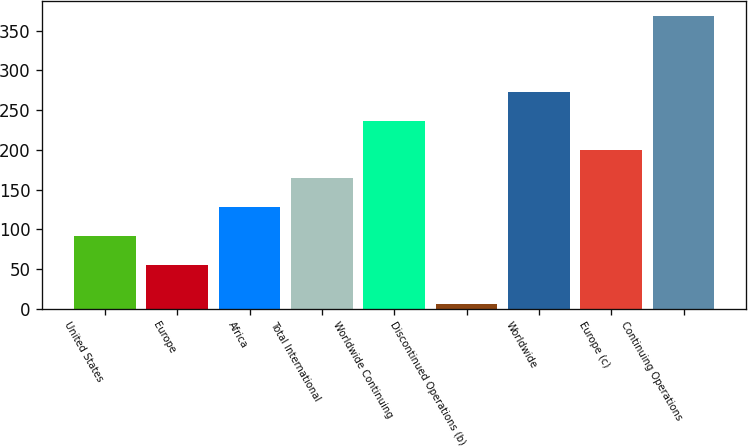Convert chart. <chart><loc_0><loc_0><loc_500><loc_500><bar_chart><fcel>United States<fcel>Europe<fcel>Africa<fcel>Total International<fcel>Worldwide Continuing<fcel>Discontinued Operations (b)<fcel>Worldwide<fcel>Europe (c)<fcel>Continuing Operations<nl><fcel>91.3<fcel>55<fcel>127.6<fcel>163.9<fcel>236.5<fcel>6<fcel>272.8<fcel>200.2<fcel>369<nl></chart> 